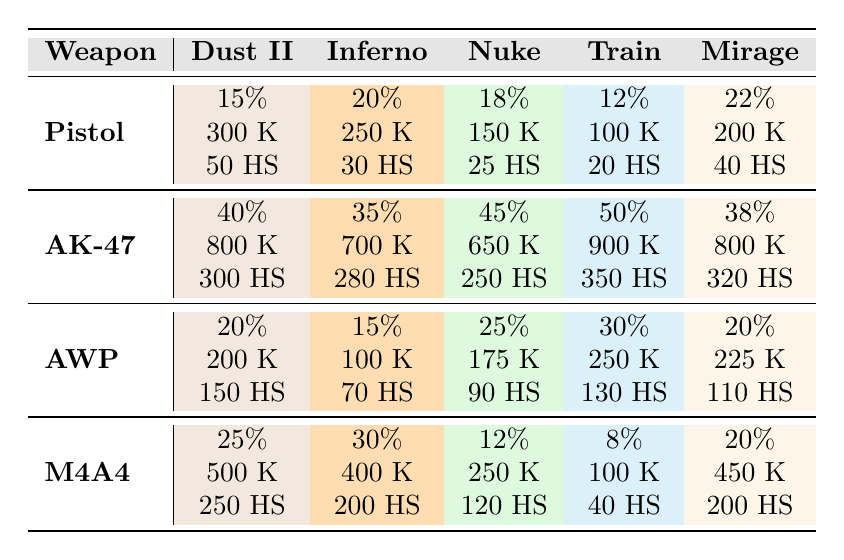What's the usage percentage of the AK-47 on Train? From the table, the AK-47's usage percentage on Train is listed under the "Train" column and is directly specified as "50%."
Answer: 50% Which weapon had the most kills on Dust II? The table shows the total kills for each weapon on Dust II: Pistol (300), AK-47 (800), AWP (200), and M4A4 (500). The AK-47 has the highest number of kills at 800.
Answer: AK-47 What is the average usage percentage of the Pistol across all maps? The Pistol's usage percentages are 15%, 20%, 18%, 12%, and 22%. To find the average, sum these percentages (15 + 20 + 18 + 12 + 22 = 87) and divide by the number of maps (5). Thus, the average is 87/5 = 17.4%.
Answer: 17.4% Is the AWP used more frequently than the Pistol on Mirage? The usage percentage for AWP on Mirage is 20%, while for the Pistol, it is 22%. Therefore, the Pistol is used more than the AWP on Mirage.
Answer: No What is the total number of headshots made with the M4A4 across all maps? The M4A4's headshot counts are: 250 (Dust II), 200 (Inferno), 120 (Nuke), 40 (Train), and 200 (Mirage). Summing these gives 250 + 200 + 120 + 40 + 200 = 810 headshots in total.
Answer: 810 Which weapon had the highest headshot percentage on Nuke? The headshots for each weapon on Nuke are: Pistol (25), AK-47 (250), AWP (90), and M4A4 (120). The AK-47 has the most headshots at 250.
Answer: AK-47 What is the difference in usage percentage of the M4A4 between Dust II and Nuke? The usage percentage for M4A4 on Dust II is 25%, and on Nuke, it is 12%. The difference is calculated as 25% - 12% = 13%.
Answer: 13% Identify the weapon with the lowest usage percentage on Train. Looking at the usage percentages for Train, they are: Pistol (12%), AK-47 (50%), AWP (30%), and M4A4 (8%). The lowest is the M4A4 at 8%.
Answer: M4A4 How many kills were made with the AWP in total across all maps? The total kills with the AWP are 200 (Dust II), 100 (Inferno), 175 (Nuke), 250 (Train), and 225 (Mirage). Adding these gives a total of 200 + 100 + 175 + 250 + 225 = 950 kills.
Answer: 950 What percentage of headshots does the AK-47 have compared to total kills on Mirage? For the AK-47 on Mirage, there are 800 total kills and 320 headshots. The headshot percentage is calculated as (320 headshots / 800 kills) * 100 = 40%.
Answer: 40% 